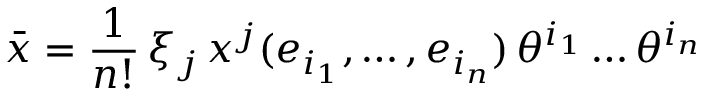Convert formula to latex. <formula><loc_0><loc_0><loc_500><loc_500>\bar { x } = \frac { 1 } { n ! } \, \xi _ { j } \, x ^ { j } ( e _ { i _ { 1 } } , \dots , e _ { i _ { n } } ) \, \theta ^ { i _ { 1 } } \dots \theta ^ { i _ { n } }</formula> 